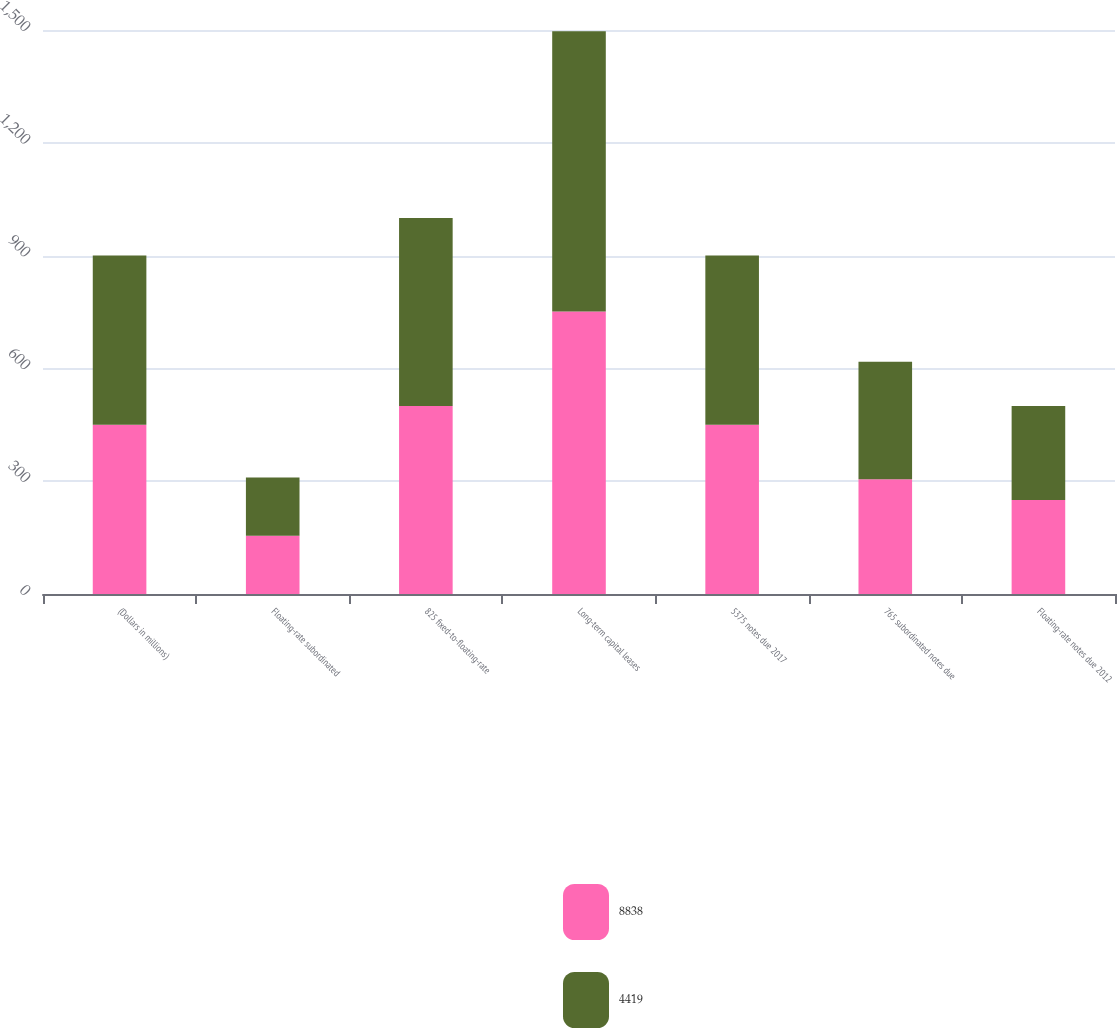Convert chart to OTSL. <chart><loc_0><loc_0><loc_500><loc_500><stacked_bar_chart><ecel><fcel>(Dollars in millions)<fcel>Floating-rate subordinated<fcel>825 fixed-to-floating-rate<fcel>Long-term capital leases<fcel>5375 notes due 2017<fcel>765 subordinated notes due<fcel>Floating-rate notes due 2012<nl><fcel>8838<fcel>450<fcel>155<fcel>500<fcel>751<fcel>450<fcel>305<fcel>250<nl><fcel>4419<fcel>450<fcel>155<fcel>500<fcel>746<fcel>450<fcel>313<fcel>250<nl></chart> 